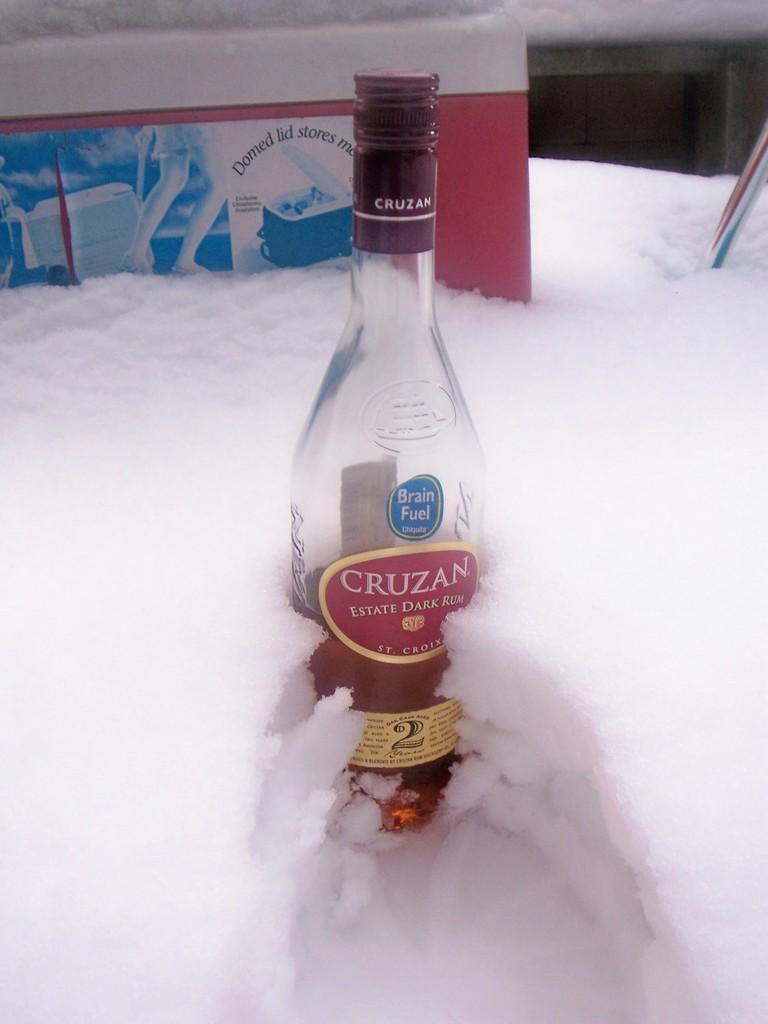What brand of beverage is pictured?
Make the answer very short. Cruzan. 